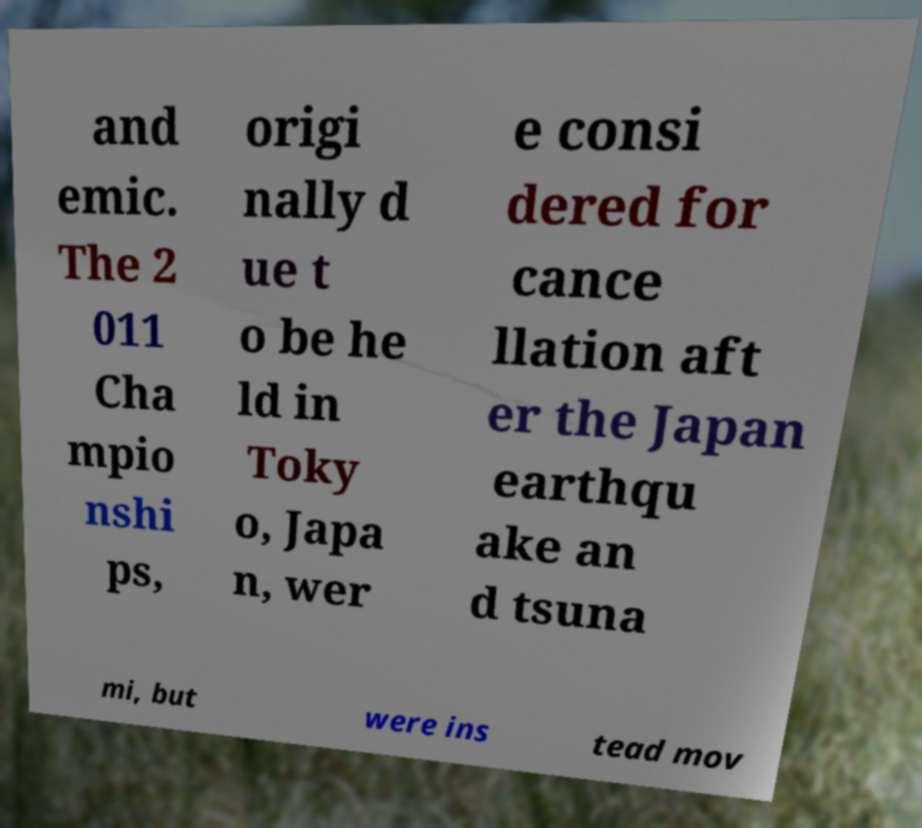What messages or text are displayed in this image? I need them in a readable, typed format. and emic. The 2 011 Cha mpio nshi ps, origi nally d ue t o be he ld in Toky o, Japa n, wer e consi dered for cance llation aft er the Japan earthqu ake an d tsuna mi, but were ins tead mov 